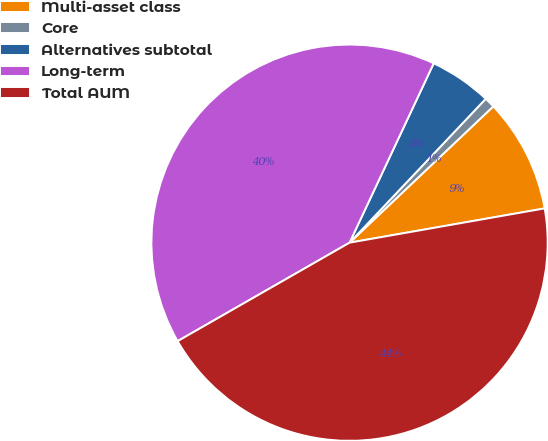Convert chart. <chart><loc_0><loc_0><loc_500><loc_500><pie_chart><fcel>Multi-asset class<fcel>Core<fcel>Alternatives subtotal<fcel>Long-term<fcel>Total AUM<nl><fcel>9.31%<fcel>0.86%<fcel>5.08%<fcel>40.26%<fcel>44.49%<nl></chart> 